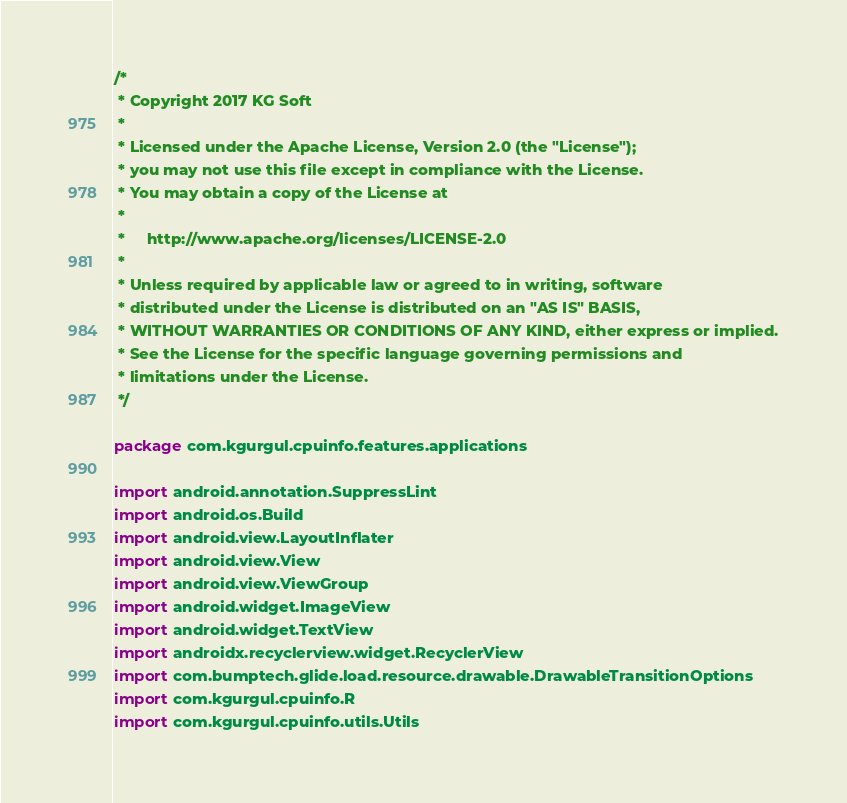Convert code to text. <code><loc_0><loc_0><loc_500><loc_500><_Kotlin_>/*
 * Copyright 2017 KG Soft
 *
 * Licensed under the Apache License, Version 2.0 (the "License");
 * you may not use this file except in compliance with the License.
 * You may obtain a copy of the License at
 *
 *     http://www.apache.org/licenses/LICENSE-2.0
 *
 * Unless required by applicable law or agreed to in writing, software
 * distributed under the License is distributed on an "AS IS" BASIS,
 * WITHOUT WARRANTIES OR CONDITIONS OF ANY KIND, either express or implied.
 * See the License for the specific language governing permissions and
 * limitations under the License.
 */

package com.kgurgul.cpuinfo.features.applications

import android.annotation.SuppressLint
import android.os.Build
import android.view.LayoutInflater
import android.view.View
import android.view.ViewGroup
import android.widget.ImageView
import android.widget.TextView
import androidx.recyclerview.widget.RecyclerView
import com.bumptech.glide.load.resource.drawable.DrawableTransitionOptions
import com.kgurgul.cpuinfo.R
import com.kgurgul.cpuinfo.utils.Utils</code> 